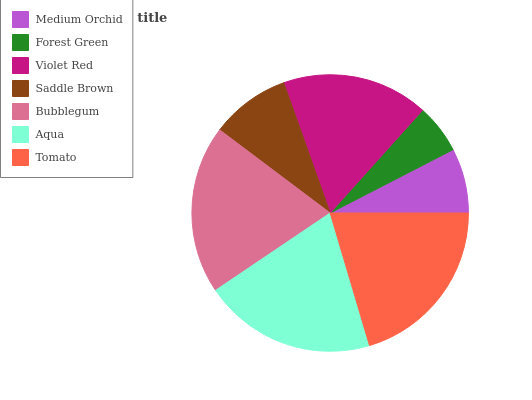Is Forest Green the minimum?
Answer yes or no. Yes. Is Tomato the maximum?
Answer yes or no. Yes. Is Violet Red the minimum?
Answer yes or no. No. Is Violet Red the maximum?
Answer yes or no. No. Is Violet Red greater than Forest Green?
Answer yes or no. Yes. Is Forest Green less than Violet Red?
Answer yes or no. Yes. Is Forest Green greater than Violet Red?
Answer yes or no. No. Is Violet Red less than Forest Green?
Answer yes or no. No. Is Violet Red the high median?
Answer yes or no. Yes. Is Violet Red the low median?
Answer yes or no. Yes. Is Forest Green the high median?
Answer yes or no. No. Is Forest Green the low median?
Answer yes or no. No. 